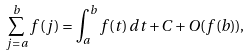Convert formula to latex. <formula><loc_0><loc_0><loc_500><loc_500>\sum _ { j = a } ^ { b } f ( j ) = \int _ { a } ^ { b } f ( t ) \, d t + C + O ( f ( b ) ) ,</formula> 